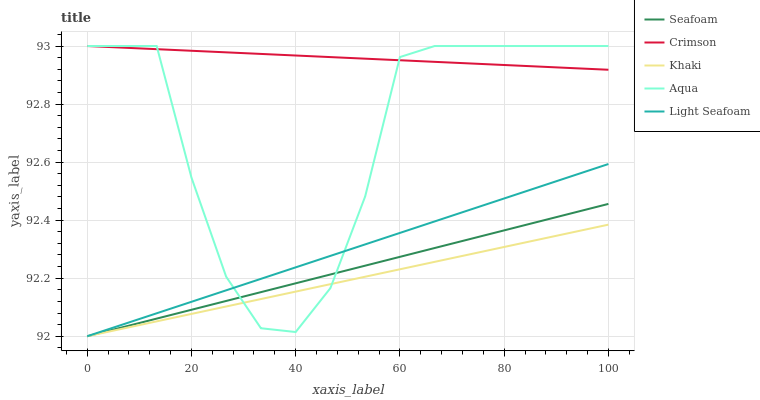Does Aqua have the minimum area under the curve?
Answer yes or no. No. Does Aqua have the maximum area under the curve?
Answer yes or no. No. Is Aqua the smoothest?
Answer yes or no. No. Is Khaki the roughest?
Answer yes or no. No. Does Aqua have the lowest value?
Answer yes or no. No. Does Khaki have the highest value?
Answer yes or no. No. Is Khaki less than Crimson?
Answer yes or no. Yes. Is Crimson greater than Khaki?
Answer yes or no. Yes. Does Khaki intersect Crimson?
Answer yes or no. No. 